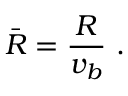<formula> <loc_0><loc_0><loc_500><loc_500>\bar { R } = \frac { R } { v _ { b } } \ .</formula> 